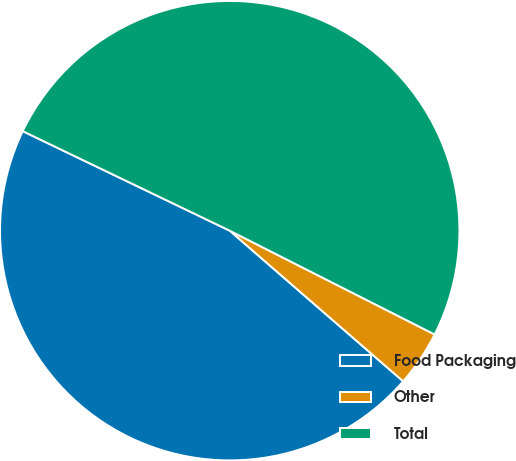Convert chart to OTSL. <chart><loc_0><loc_0><loc_500><loc_500><pie_chart><fcel>Food Packaging<fcel>Other<fcel>Total<nl><fcel>45.75%<fcel>3.92%<fcel>50.33%<nl></chart> 